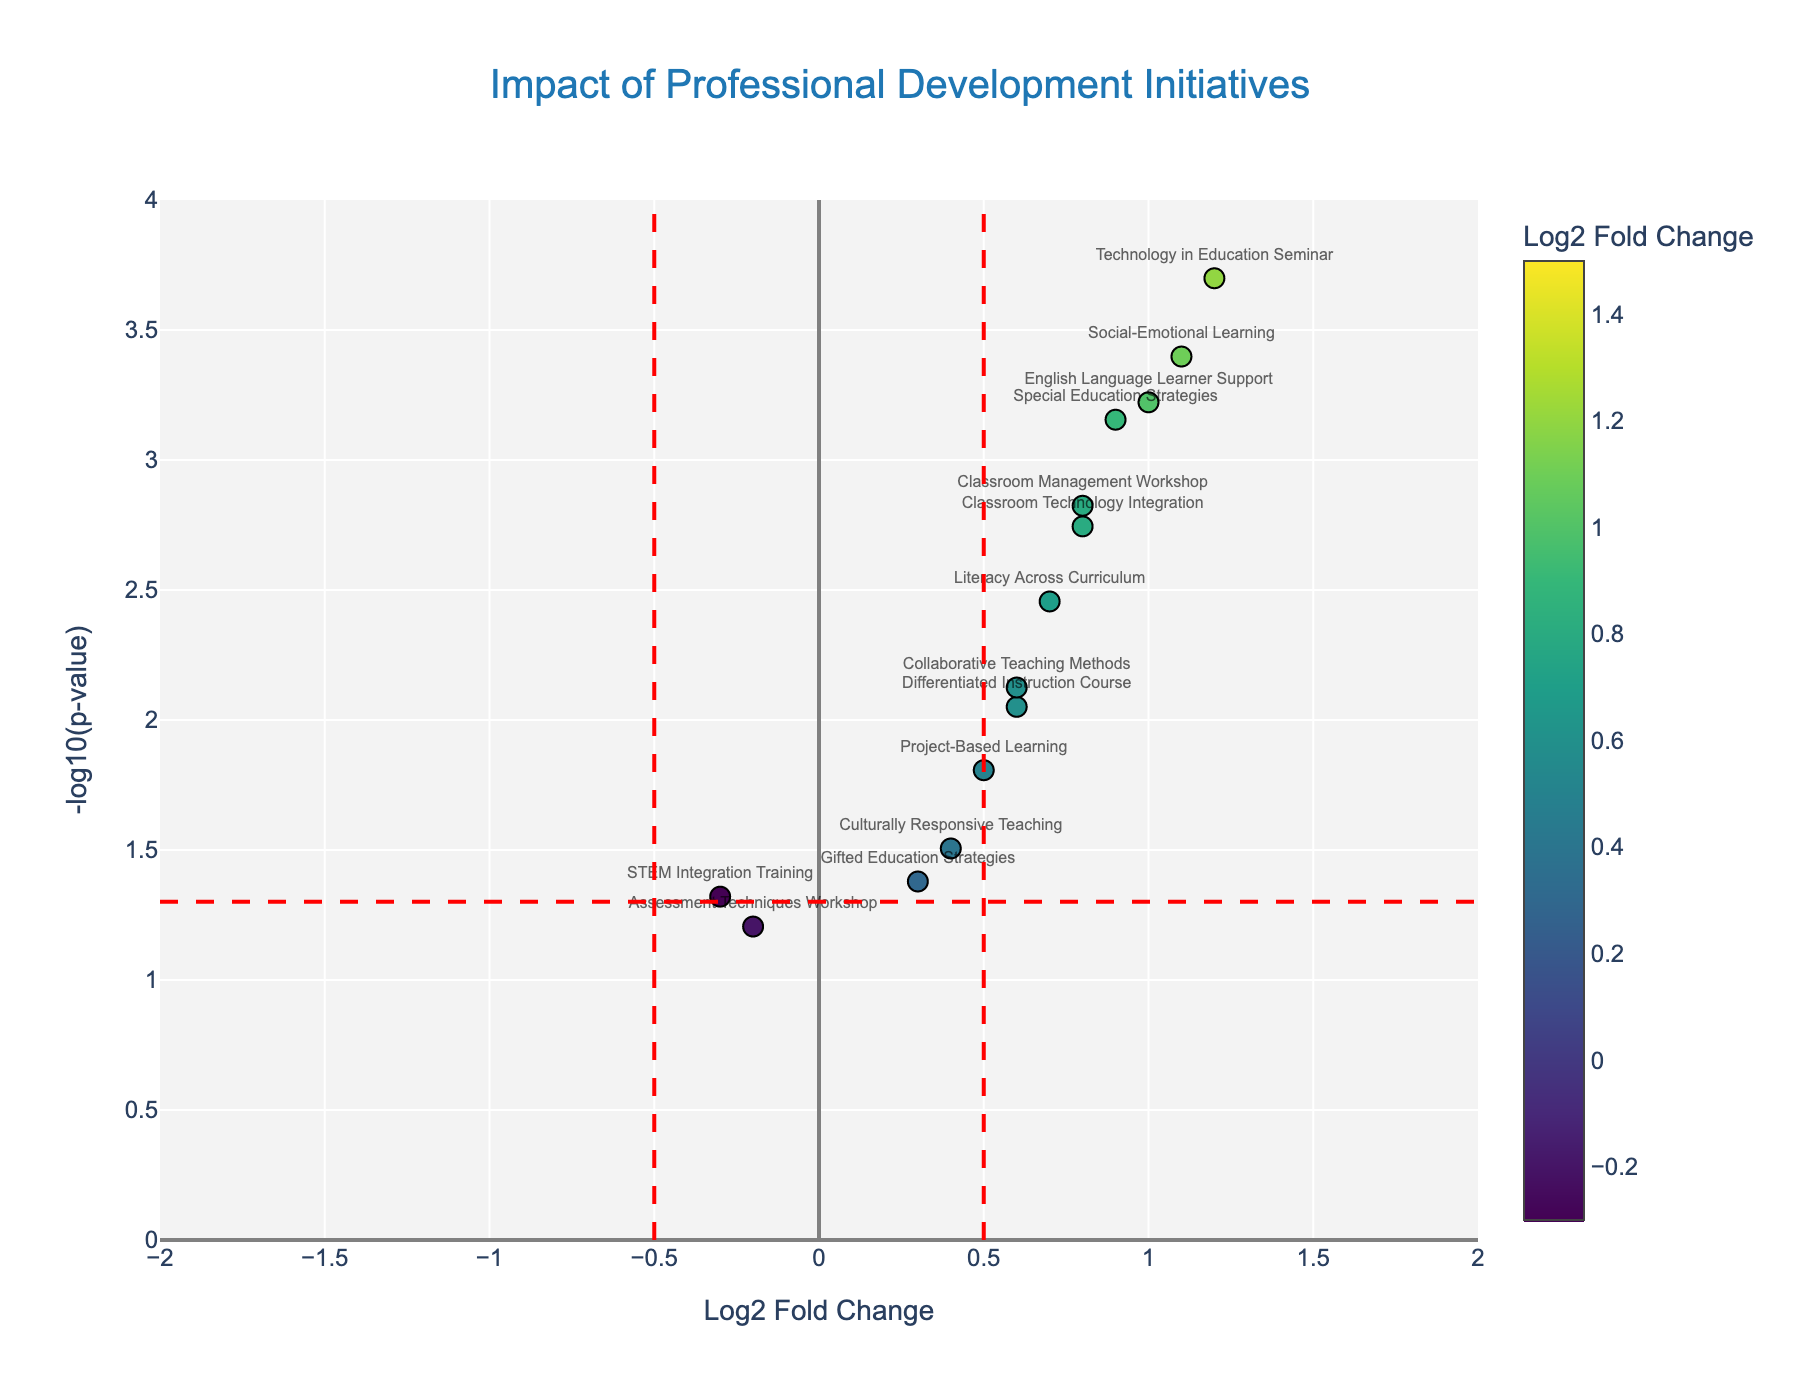What's the title of the figure? The figure's title is often placed at the top and is designed to provide an overview of the visualized data. In this case, the title is "Impact of Professional Development Initiatives," indicating that the figure shows how different professional development programs affect teacher performance and student outcomes.
Answer: Impact of Professional Development Initiatives How many initiatives have a positive Log2 Fold Change? Positive Log2 Fold Changes are those above 0. To determine the number, count all initiatives with positive fold changes in the range (0, 2].
Answer: 12 Which initiative has the highest negative Log2 Fold Change, and what is its P-value? Negative Log2 Fold Changes are below 0. The lowest value here is -0.3 for "STEM Integration Training". The corresponding P-value can be found directly next to this initiative in the data table.
Answer: STEM Integration Training, 0.0478 What are the axes labels for this figure? Axes labels usually describe the plotted data types. The x-axis label, "Log2 Fold Change," indicates the effect size of professional development initiatives. The y-axis label, "-log10(p-value)," shows the statistical significance of these effects.
Answer: Log2 Fold Change, -log10(p-value) How many initiatives are above the significance threshold line for P-value (less than 0.05)? The significance threshold line on the y-axis is determined by -log10(0.05). By counting the number of points above this line on the y-axis, we find these are 10 initiatives.
Answer: 12 Which initiatives are considered most impactful based on the highest fold change and lowest P-value? The initiatives with the highest fold changes and lowest P-values are those in the top right portion of the plot. Observing these, "Data-Driven Decision Making," "Technology in Education Seminar," and "Social-Emotional Learning" stand out.
Answer: Data-Driven Decision Making, Technology in Education Seminar, Social-Emotional Learning What initiatives are plotted closest to the threshold line for Log2 Fold Change? The threshold lines for Log2 Fold Change are at -0.5 and 0.5. Initiatives close to these lines would have Log2 Fold Changes near -0.5 and 0.5. "Assessment Techniques Workshop" and "Project-Based Learning" are close to these values respectively.
Answer: Assessment Techniques Workshop, Project-Based Learning Which initiative shows the greatest improvement and how is it reflected on the plot? The greatest improvement is indicated by the highest Log2 Fold Change with a significant p-value, observed as the highest point on the y-axis. "Data-Driven Decision Making," with a Log2 Fold Change of 1.5 and a very significant p-value (very small), reflects this.
Answer: Data-Driven Decision Making What is the P-value threshold used to determine significance in this plot? The significance threshold is set visually on the plot by a horizontal line, usually at -log10(0.05). Converting this gives a P-value of 0.05, demarcating significant initiatives.
Answer: 0.05 What color represents the highest Log2 Fold Change, and which initiatives fall into this category? Color scales indicate change magnitudes; the most intense color likelier represents the highest change. Initiatives fitting here are those like "Data-Driven Decision Making" due to their high positive fold changes.
Answer: Most intense color, Data-Driven Decision Making, Social-Emotional Learning 